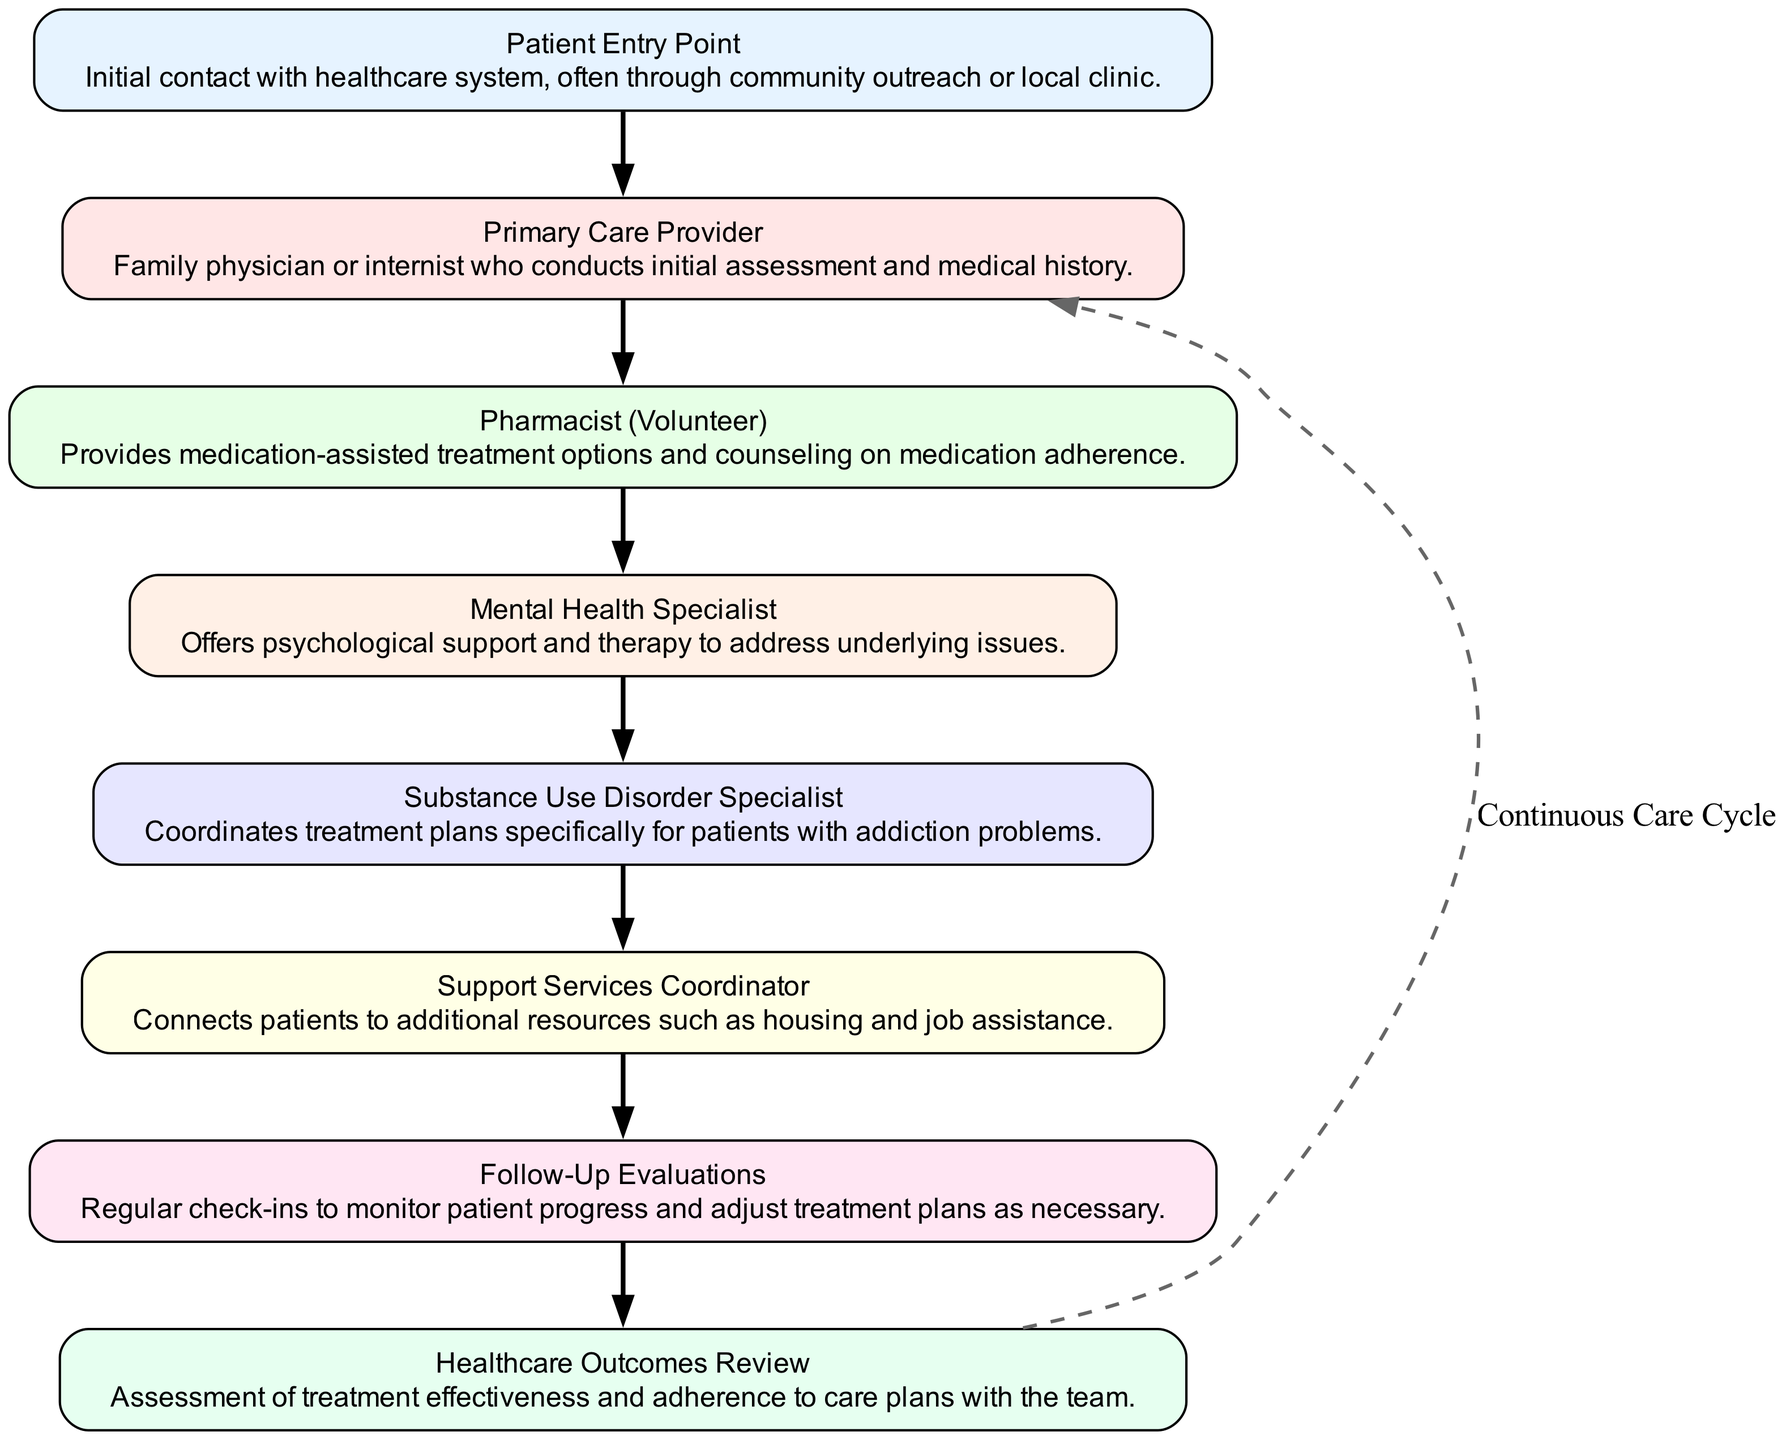What is the entry point into the healthcare system? The diagram indicates that the initial contact with the healthcare system is made at "Patient Entry Point."
Answer: Patient Entry Point How many nodes are present in the diagram? Counting all the elements listed in the diagram, there are eight nodes that represent different stages or roles in the flow of collaboration.
Answer: 8 What role does the "Pharmacist (Volunteer)" play in the patient care flow? The "Pharmacist (Volunteer)" is responsible for providing medication-assisted treatment options and counseling on adherence, which means they play a key role in managing the patient's medication needs.
Answer: Provides medication-assisted treatment options and counseling on medication adherence Which node follows the "Primary Care Provider"? According to the flow of the diagram, the "Pharmacist (Volunteer)" comes next after the "Primary Care Provider."
Answer: Pharmacist (Volunteer) How does the flow of collaboration loop back to the "Primary Care Provider"? The flow chart shows a dashed line labeled "Continuous Care Cycle," which connects the last node "Healthcare Outcomes Review" back to the "Primary Care Provider," indicating an ongoing cycle of care.
Answer: Continuous Care Cycle What is the function of the "Support Services Coordinator"? The "Support Services Coordinator" connects patients to additional resources such as housing and job assistance, highlighting the role of support services in patient care.
Answer: Connects patients to additional resources such as housing and job assistance What comes after the "Mental Health Specialist" in the collaboration flow? Following the "Mental Health Specialist," the next node in the sequence is the "Substance Use Disorder Specialist," indicating the progression of care focusing on addiction.
Answer: Substance Use Disorder Specialist How many edges connect the nodes in the diagram? The diagram has seven directed edges connecting the eight nodes, indicating the flow of information and care between them.
Answer: 7 